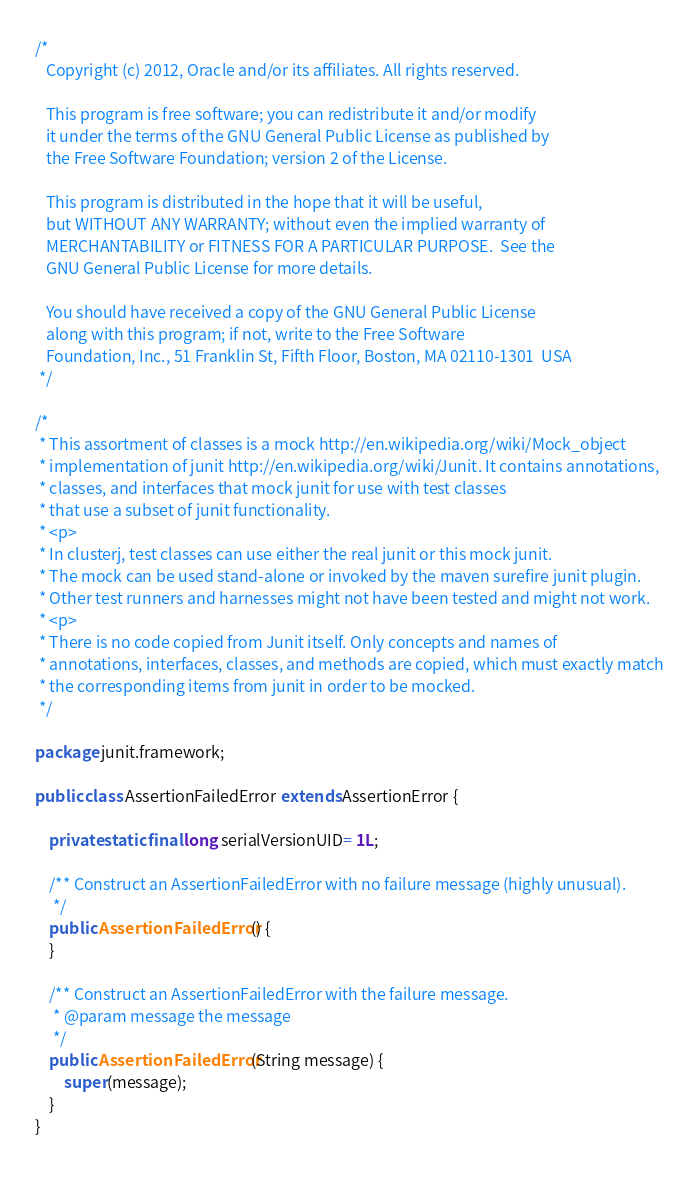<code> <loc_0><loc_0><loc_500><loc_500><_Java_>/*
   Copyright (c) 2012, Oracle and/or its affiliates. All rights reserved.

   This program is free software; you can redistribute it and/or modify
   it under the terms of the GNU General Public License as published by
   the Free Software Foundation; version 2 of the License.

   This program is distributed in the hope that it will be useful,
   but WITHOUT ANY WARRANTY; without even the implied warranty of
   MERCHANTABILITY or FITNESS FOR A PARTICULAR PURPOSE.  See the
   GNU General Public License for more details.

   You should have received a copy of the GNU General Public License
   along with this program; if not, write to the Free Software
   Foundation, Inc., 51 Franklin St, Fifth Floor, Boston, MA 02110-1301  USA
 */

/*
 * This assortment of classes is a mock http://en.wikipedia.org/wiki/Mock_object
 * implementation of junit http://en.wikipedia.org/wiki/Junit. It contains annotations,
 * classes, and interfaces that mock junit for use with test classes 
 * that use a subset of junit functionality. 
 * <p>
 * In clusterj, test classes can use either the real junit or this mock junit.
 * The mock can be used stand-alone or invoked by the maven surefire junit plugin.
 * Other test runners and harnesses might not have been tested and might not work.
 * <p>
 * There is no code copied from Junit itself. Only concepts and names of
 * annotations, interfaces, classes, and methods are copied, which must exactly match
 * the corresponding items from junit in order to be mocked.
 */

package junit.framework;

public class AssertionFailedError extends AssertionError {

    private static final long serialVersionUID= 1L;

    /** Construct an AssertionFailedError with no failure message (highly unusual).
     */
    public AssertionFailedError() {
    }

    /** Construct an AssertionFailedError with the failure message.
     * @param message the message
     */
    public AssertionFailedError(String message) {
        super(message);
    }
}
 </code> 